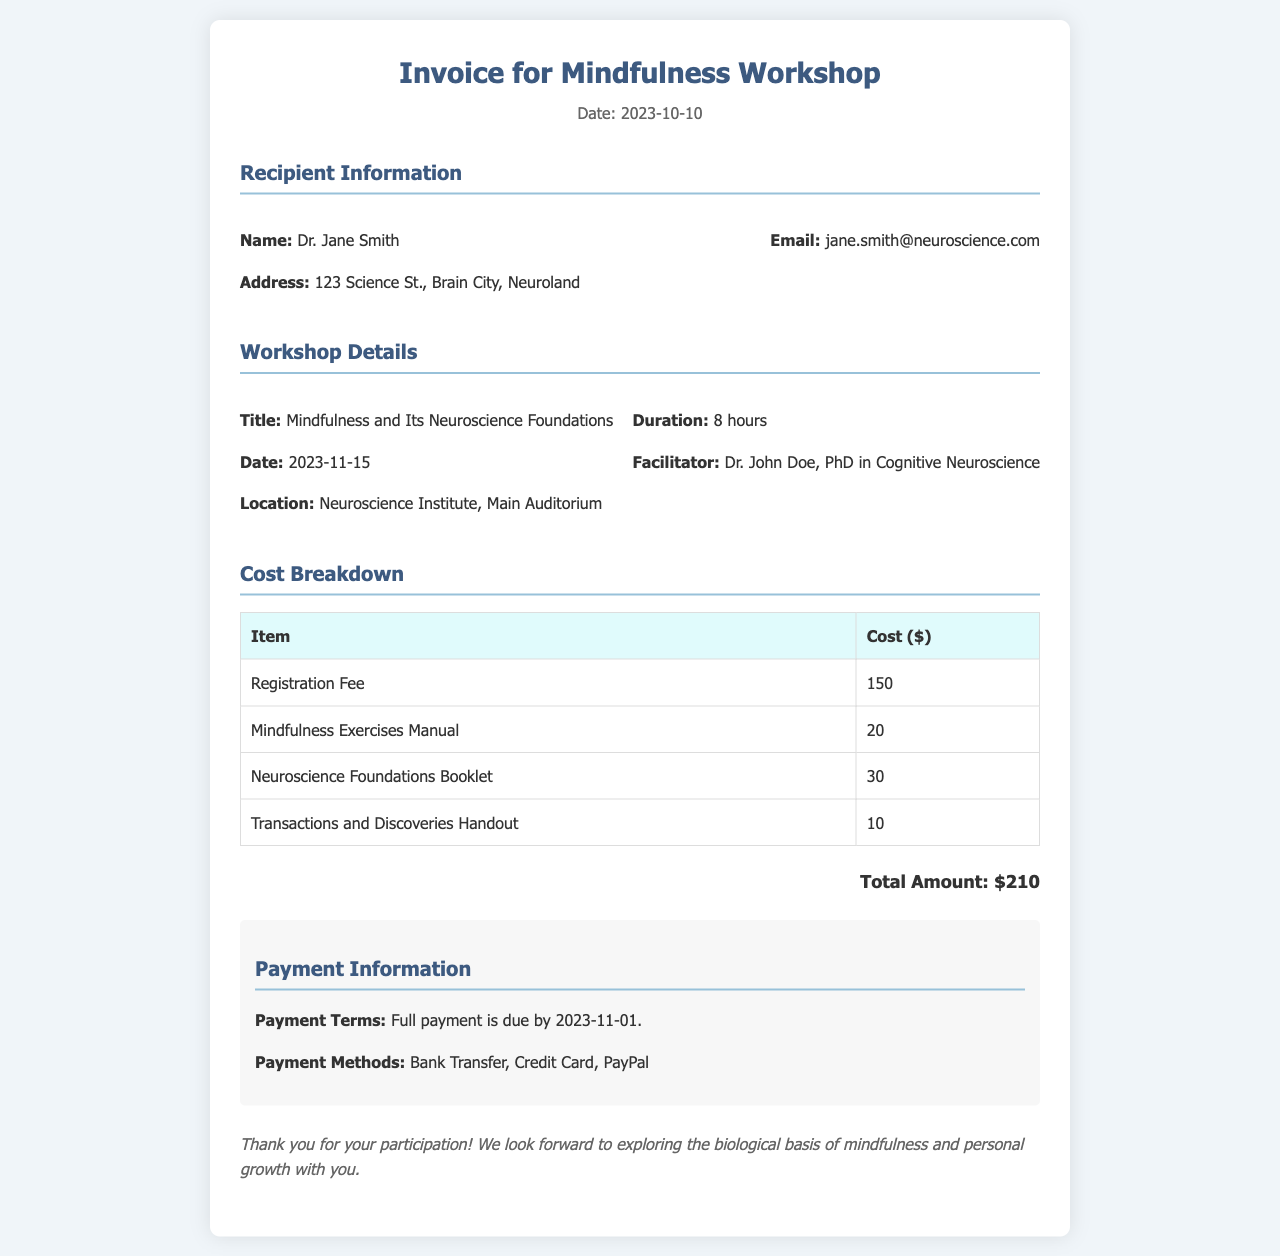What is the name of the recipient? The recipient's name is listed under the recipient information section of the document.
Answer: Dr. Jane Smith What date is the workshop scheduled for? The workshop date can be found in the workshop details section.
Answer: 2023-11-15 What is the total amount due? The total amount is summarized in the cost breakdown section of the document.
Answer: $210 Who is the facilitator of the workshop? The name of the facilitator is mentioned in the workshop details section.
Answer: Dr. John Doe, PhD in Cognitive Neuroscience What is the payment terms due date? The payment terms due date is specified in the payment information section of the document.
Answer: 2023-11-01 How long is the workshop? The duration of the workshop is indicated in the workshop details section.
Answer: 8 hours What types of payment methods are accepted? The accepted payment methods are detailed in the payment information section.
Answer: Bank Transfer, Credit Card, PayPal What is included in the cost breakdown for materials? The cost breakdown lists all materials included; it's mentioned in the cost breakdown section.
Answer: Mindfulness Exercises Manual, Neuroscience Foundations Booklet, Transactions and Discoveries Handout 